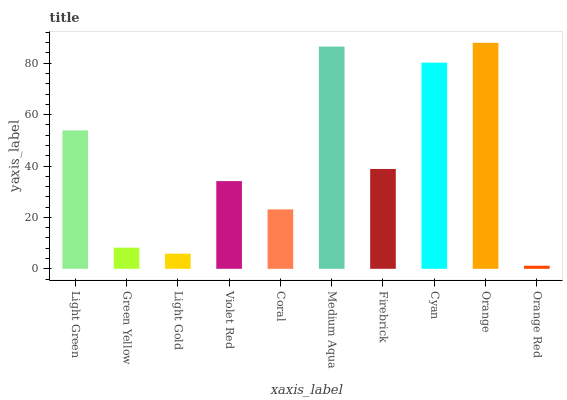Is Orange Red the minimum?
Answer yes or no. Yes. Is Orange the maximum?
Answer yes or no. Yes. Is Green Yellow the minimum?
Answer yes or no. No. Is Green Yellow the maximum?
Answer yes or no. No. Is Light Green greater than Green Yellow?
Answer yes or no. Yes. Is Green Yellow less than Light Green?
Answer yes or no. Yes. Is Green Yellow greater than Light Green?
Answer yes or no. No. Is Light Green less than Green Yellow?
Answer yes or no. No. Is Firebrick the high median?
Answer yes or no. Yes. Is Violet Red the low median?
Answer yes or no. Yes. Is Cyan the high median?
Answer yes or no. No. Is Cyan the low median?
Answer yes or no. No. 